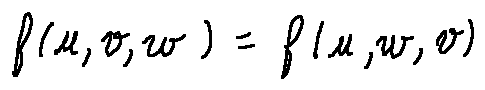Convert formula to latex. <formula><loc_0><loc_0><loc_500><loc_500>f ( u , v , w ) = f ( u , w , v )</formula> 